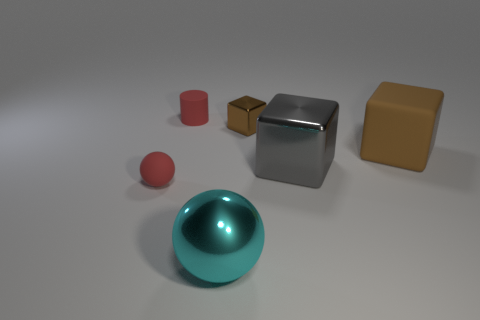What number of other objects are the same shape as the large cyan thing?
Provide a succinct answer. 1. Is there a tiny red ball made of the same material as the big cyan object?
Give a very brief answer. No. What is the color of the large matte thing?
Offer a very short reply. Brown. How big is the red object behind the small red ball?
Provide a short and direct response. Small. How many tiny cylinders are the same color as the tiny ball?
Ensure brevity in your answer.  1. Is there a small red object that is on the right side of the small red object in front of the big gray metal thing?
Offer a terse response. Yes. Does the small matte object that is behind the tiny brown shiny thing have the same color as the rubber thing in front of the big metal block?
Ensure brevity in your answer.  Yes. What is the color of the other rubber object that is the same size as the gray thing?
Provide a short and direct response. Brown. Are there the same number of tiny things that are behind the brown metal thing and brown metallic blocks that are in front of the gray thing?
Your answer should be very brief. No. What is the material of the red thing in front of the large cube that is left of the large brown matte cube?
Keep it short and to the point. Rubber. 